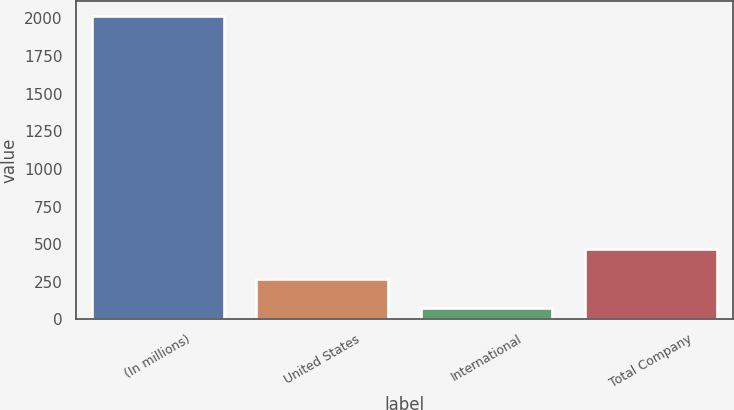Convert chart to OTSL. <chart><loc_0><loc_0><loc_500><loc_500><bar_chart><fcel>(In millions)<fcel>United States<fcel>International<fcel>Total Company<nl><fcel>2015<fcel>271.97<fcel>78.3<fcel>465.64<nl></chart> 